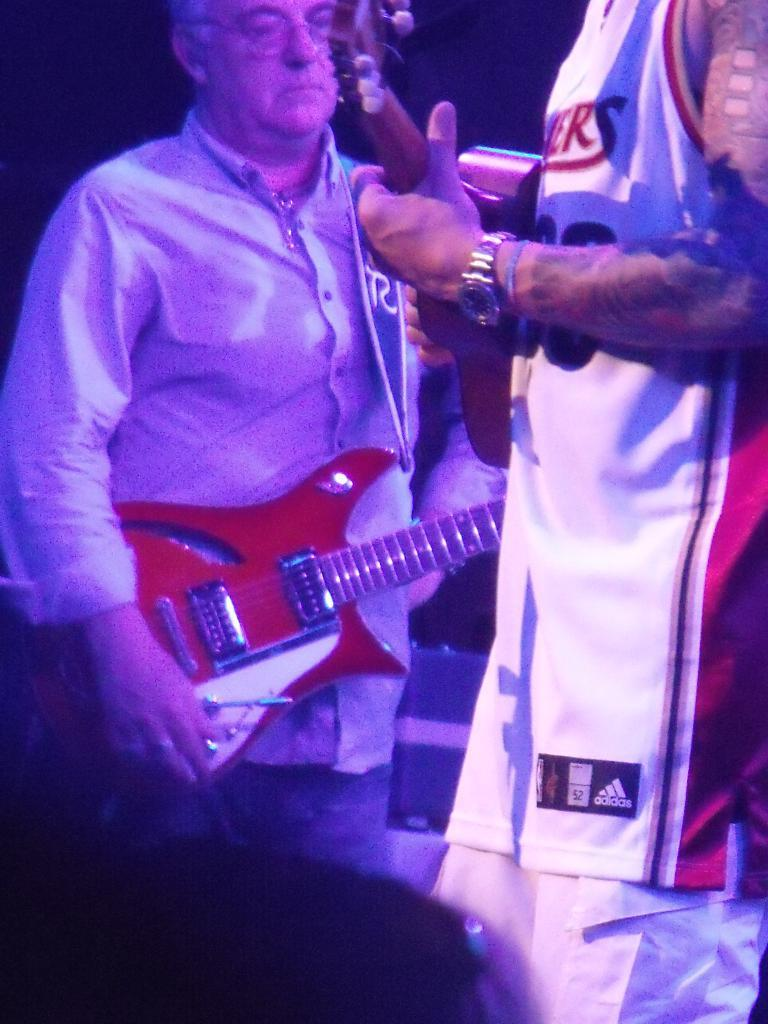What is the man in the image doing? The man is standing in the image and holding a guitar in his hand. Are there any other people in the image? Yes, there is another person standing in the image. What is the other person holding in his hand? The other person is also holding a guitar in his hand. What type of poison is the man using to play the guitar in the image? There is no poison present in the image, and the man is not using any to play the guitar. 